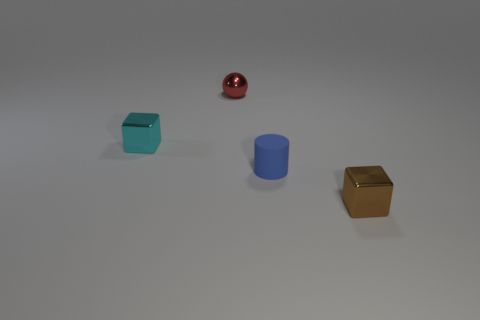Subtract all cyan cubes. How many cubes are left? 1 Add 1 small metal objects. How many objects exist? 5 Subtract all balls. How many objects are left? 3 Subtract all gray spheres. How many brown cubes are left? 1 Subtract 0 gray blocks. How many objects are left? 4 Subtract all gray cubes. Subtract all blue spheres. How many cubes are left? 2 Subtract all spheres. Subtract all shiny cubes. How many objects are left? 1 Add 3 small things. How many small things are left? 7 Add 4 cyan shiny cubes. How many cyan shiny cubes exist? 5 